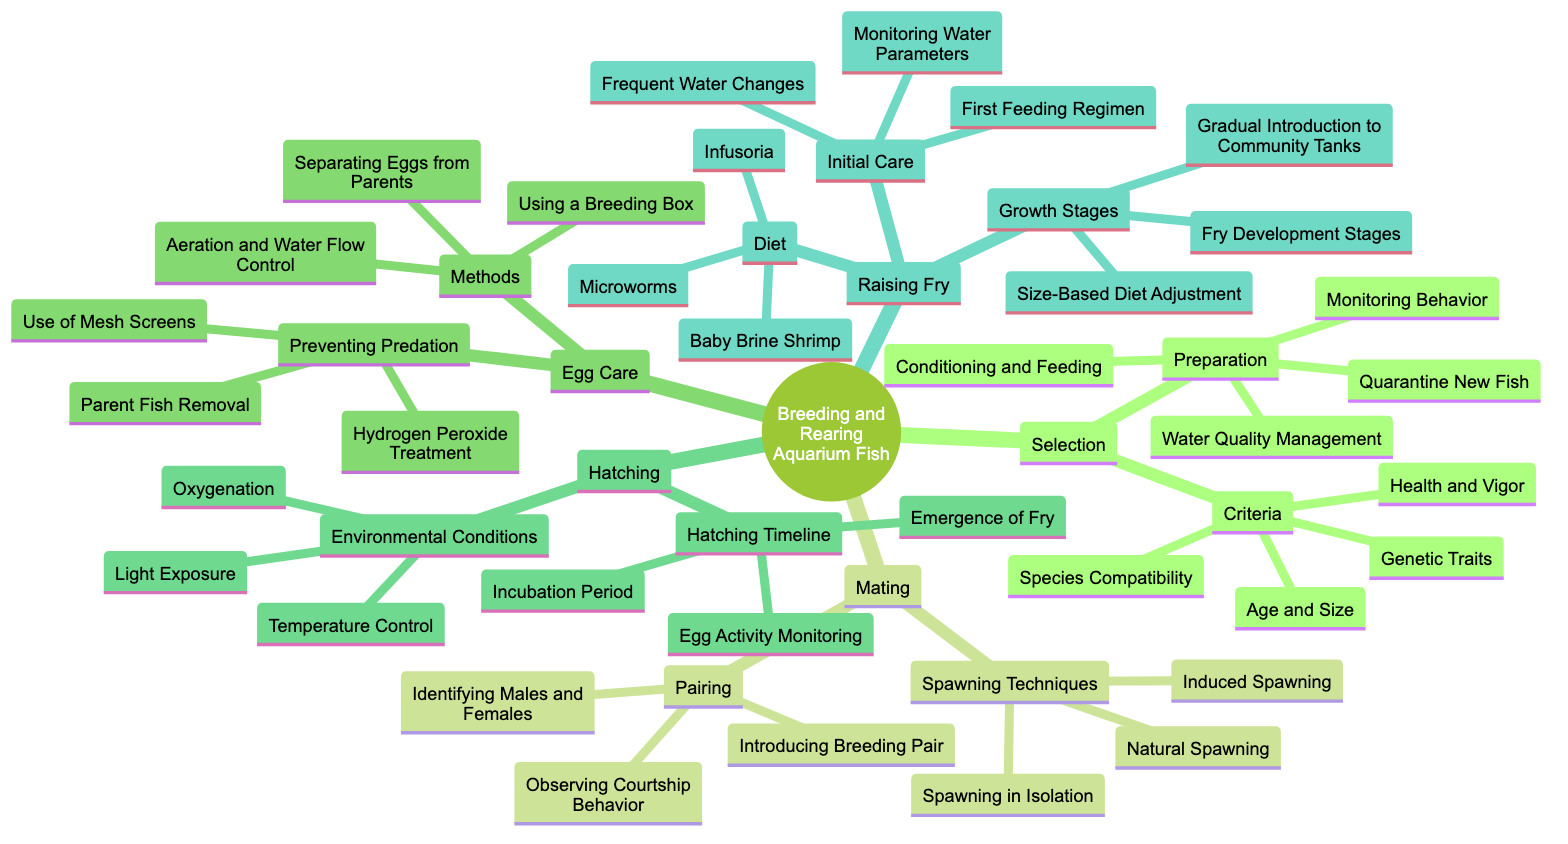What are the four criteria for selection in breeding aquarium fish? The diagram shows the selection section, specifically under the criteria node, which lists four factors that include Species Compatibility, Health and Vigor, Age and Size, and Genetic Traits.
Answer: Species Compatibility, Health and Vigor, Age and Size, Genetic Traits How many methods are there for egg care? The egg care section of the diagram has a 'Methods' node that lists three distinct methods: Using a Breeding Box, Separating Eggs from Parents, and Aeration and Water Flow Control. Therefore, the answer is obtained by counting these listed methods.
Answer: 3 What is the first feeding regimen for fry? In the Raising Fry section, within the 'Initial Care' node, it states that the first feeding regimen is one of the essential aspects of caring for fry. This information can be directly found under that section of the diagram.
Answer: First Feeding Regimen What is a key factor in the hatching timeline? The diagram specifies that within the 'Hatching' section, there is a 'Hatching Timeline' node which mentions Incubation Period, Egg Activity Monitoring, and Emergence of Fry. All of these can be considered key factors, but the question asks for one which is easy to identify. Incubation Period could be a straightforward choice for a key factor.
Answer: Incubation Period What should be monitored during the preparation stage of selection? Looking under the preparation node within the Selection section of the diagram, one of the requirements is Monitoring Behavior, which is essential to ensure the fish are suitable for breeding. This node clearly answers the question based on the content provided in the diagram.
Answer: Monitoring Behavior Which spawning technique involves interacting directly with the breeding pair? The 'Spawning Techniques' node within the Mating section of the diagram lists Natural Spawning, Induced Spawning, and Spawning in Isolation. Induced Spawning can be singled out as the technique where direct interaction with the breeding pair is involved for the process.
Answer: Induced Spawning How many growth stages are indicated for raising fry? The diagram under the Raising Fry section contains a 'Growth Stages' node that explicitly lists Fry Development Stages, Size-Based Diet Adjustment, and Gradual Introduction to Community Tanks, which totals to three distinct growth stages mentioned in the process of raising fry.
Answer: 3 What is one method to prevent predation in egg care? The diagram indicates under the 'Preventing Predation' node in the Egg Care section the option of Parent Fish Removal, which is one of the documented methods to protect the eggs from being eaten by the parent fish themselves.
Answer: Parent Fish Removal 